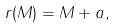Convert formula to latex. <formula><loc_0><loc_0><loc_500><loc_500>r ( M ) = M + a ,</formula> 